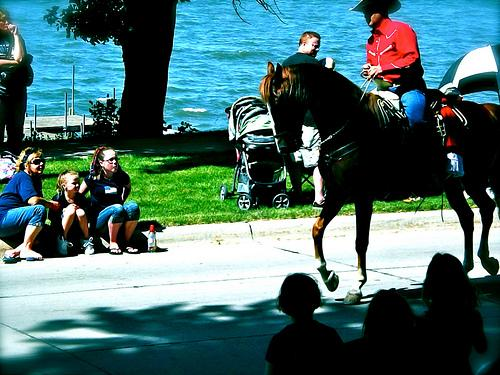State the number of people sitting on the curb and their attire. Three people sitting on the curb, two girls wearing pedal pushers and one woman with sandals off. What type of trees can be seen in the image? There is a shaded tree trunk and a tree in the background. Name two actions individuals in the image are engaged in. Riding a horse and sitting on the curb. Describe the footwear worn by the girl in the image. The girl is wearing sandals (flipflops) in the image. Identify the primary activity happening in the picture. Man riding a horse on a street near people sitting on the curb. Where is the baby stroller located and what is its distinguishing feature? The baby stroller is on the grass and is shaded with a towel. Mention the color of the shirt a man is wearing in the image and what he is doing. Man is wearing a red shirt and riding a horse. What type of animal is featured prominently in the image? A horse is prominently featured in the image. Select the appropriate caption for the image: a) three girls playing soccer, b) man riding a horse near people sitting on the curb, c) people swimming in a pool Man riding a horse near people sitting on the curb. List three objects or accessories people have with them in the image. A baby stroller, a black and white umbrella, and a plastic bottle. 